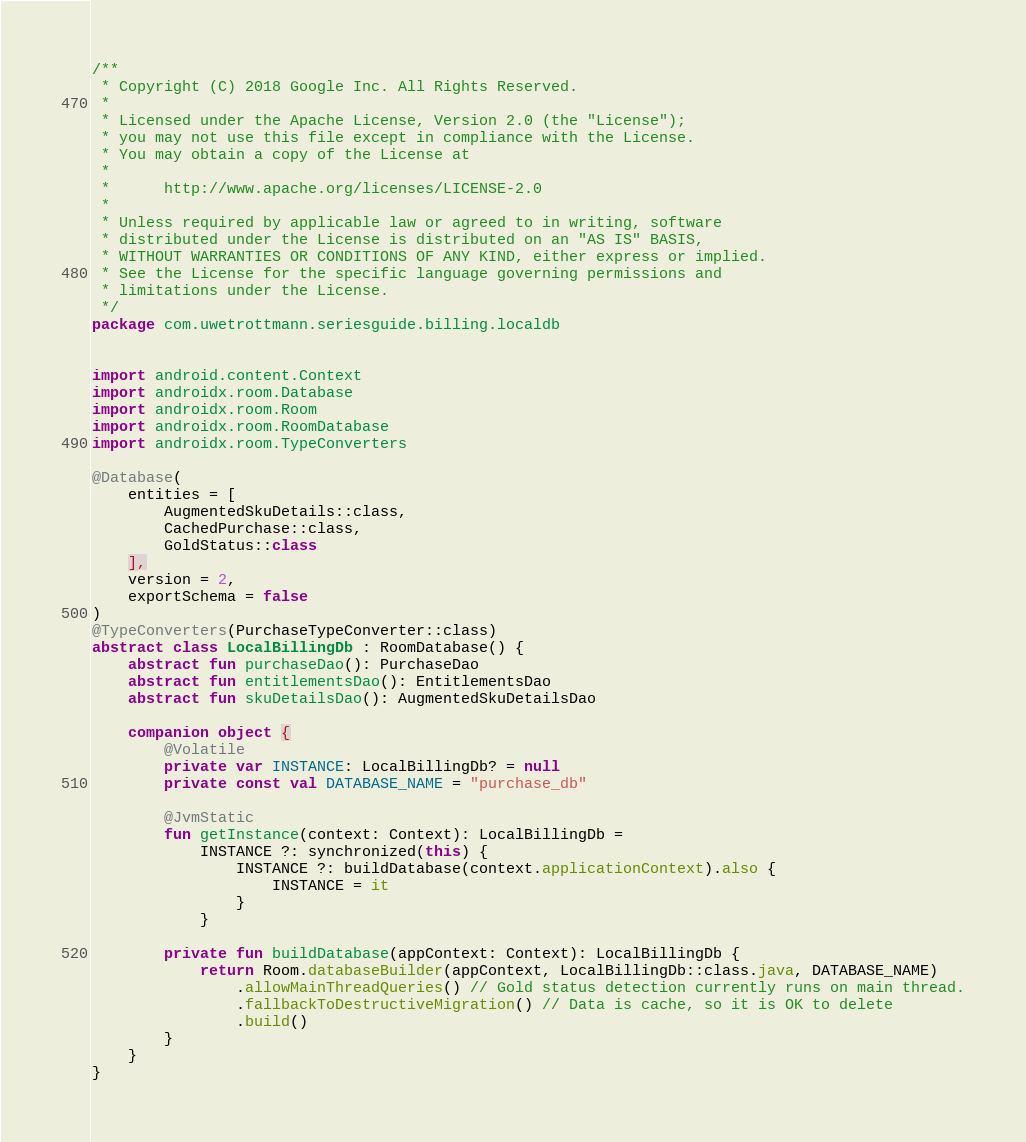Convert code to text. <code><loc_0><loc_0><loc_500><loc_500><_Kotlin_>/**
 * Copyright (C) 2018 Google Inc. All Rights Reserved.
 *
 * Licensed under the Apache License, Version 2.0 (the "License");
 * you may not use this file except in compliance with the License.
 * You may obtain a copy of the License at
 *
 *      http://www.apache.org/licenses/LICENSE-2.0
 *
 * Unless required by applicable law or agreed to in writing, software
 * distributed under the License is distributed on an "AS IS" BASIS,
 * WITHOUT WARRANTIES OR CONDITIONS OF ANY KIND, either express or implied.
 * See the License for the specific language governing permissions and
 * limitations under the License.
 */
package com.uwetrottmann.seriesguide.billing.localdb


import android.content.Context
import androidx.room.Database
import androidx.room.Room
import androidx.room.RoomDatabase
import androidx.room.TypeConverters

@Database(
    entities = [
        AugmentedSkuDetails::class,
        CachedPurchase::class,
        GoldStatus::class
    ],
    version = 2,
    exportSchema = false
)
@TypeConverters(PurchaseTypeConverter::class)
abstract class LocalBillingDb : RoomDatabase() {
    abstract fun purchaseDao(): PurchaseDao
    abstract fun entitlementsDao(): EntitlementsDao
    abstract fun skuDetailsDao(): AugmentedSkuDetailsDao

    companion object {
        @Volatile
        private var INSTANCE: LocalBillingDb? = null
        private const val DATABASE_NAME = "purchase_db"

        @JvmStatic
        fun getInstance(context: Context): LocalBillingDb =
            INSTANCE ?: synchronized(this) {
                INSTANCE ?: buildDatabase(context.applicationContext).also {
                    INSTANCE = it
                }
            }

        private fun buildDatabase(appContext: Context): LocalBillingDb {
            return Room.databaseBuilder(appContext, LocalBillingDb::class.java, DATABASE_NAME)
                .allowMainThreadQueries() // Gold status detection currently runs on main thread.
                .fallbackToDestructiveMigration() // Data is cache, so it is OK to delete
                .build()
        }
    }
}
</code> 